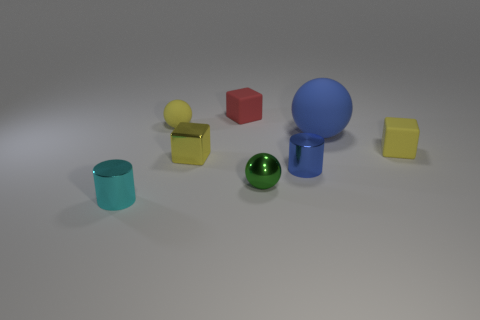Subtract all yellow blocks. How many blocks are left? 1 Subtract all green spheres. How many spheres are left? 2 Add 1 big blue matte spheres. How many objects exist? 9 Subtract all cylinders. How many objects are left? 6 Add 3 shiny spheres. How many shiny spheres are left? 4 Add 2 yellow spheres. How many yellow spheres exist? 3 Subtract 1 yellow balls. How many objects are left? 7 Subtract 1 cubes. How many cubes are left? 2 Subtract all green blocks. Subtract all green cylinders. How many blocks are left? 3 Subtract all purple cylinders. How many blue spheres are left? 1 